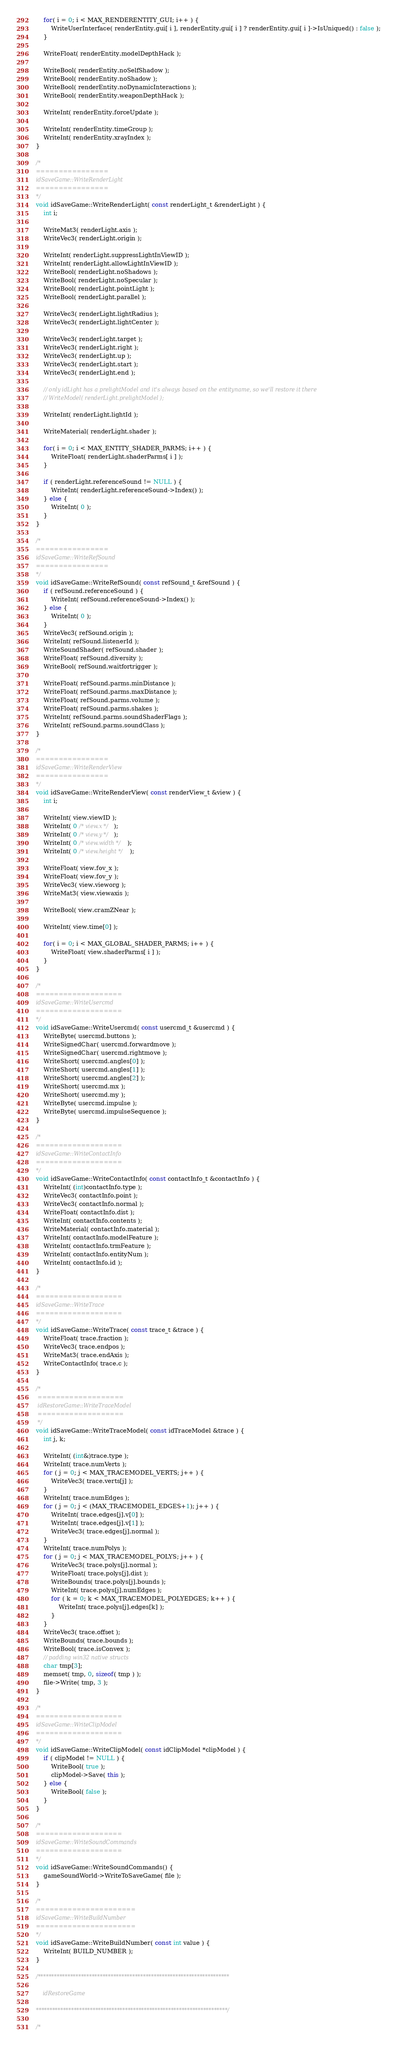Convert code to text. <code><loc_0><loc_0><loc_500><loc_500><_C++_>
	for( i = 0; i < MAX_RENDERENTITY_GUI; i++ ) {
		WriteUserInterface( renderEntity.gui[ i ], renderEntity.gui[ i ] ? renderEntity.gui[ i ]->IsUniqued() : false );
	}

	WriteFloat( renderEntity.modelDepthHack );

	WriteBool( renderEntity.noSelfShadow );
	WriteBool( renderEntity.noShadow );
	WriteBool( renderEntity.noDynamicInteractions );
	WriteBool( renderEntity.weaponDepthHack );

	WriteInt( renderEntity.forceUpdate );

	WriteInt( renderEntity.timeGroup );
	WriteInt( renderEntity.xrayIndex );
}

/*
================
idSaveGame::WriteRenderLight
================
*/
void idSaveGame::WriteRenderLight( const renderLight_t &renderLight ) {
	int i;

	WriteMat3( renderLight.axis );
	WriteVec3( renderLight.origin );

	WriteInt( renderLight.suppressLightInViewID );
	WriteInt( renderLight.allowLightInViewID );
	WriteBool( renderLight.noShadows );
	WriteBool( renderLight.noSpecular );
	WriteBool( renderLight.pointLight );
	WriteBool( renderLight.parallel );

	WriteVec3( renderLight.lightRadius );
	WriteVec3( renderLight.lightCenter );

	WriteVec3( renderLight.target );
	WriteVec3( renderLight.right );
	WriteVec3( renderLight.up );
	WriteVec3( renderLight.start );
	WriteVec3( renderLight.end );

	// only idLight has a prelightModel and it's always based on the entityname, so we'll restore it there
	// WriteModel( renderLight.prelightModel );

	WriteInt( renderLight.lightId );

	WriteMaterial( renderLight.shader );

	for( i = 0; i < MAX_ENTITY_SHADER_PARMS; i++ ) {
		WriteFloat( renderLight.shaderParms[ i ] );
	}

	if ( renderLight.referenceSound != NULL ) {
		WriteInt( renderLight.referenceSound->Index() );
	} else {
		WriteInt( 0 );
	}
}

/*
================
idSaveGame::WriteRefSound
================
*/
void idSaveGame::WriteRefSound( const refSound_t &refSound ) {
	if ( refSound.referenceSound ) {
		WriteInt( refSound.referenceSound->Index() );
	} else {
		WriteInt( 0 );
	}
	WriteVec3( refSound.origin );
	WriteInt( refSound.listenerId );
	WriteSoundShader( refSound.shader );
	WriteFloat( refSound.diversity );
	WriteBool( refSound.waitfortrigger );

	WriteFloat( refSound.parms.minDistance );
	WriteFloat( refSound.parms.maxDistance );
	WriteFloat( refSound.parms.volume );
	WriteFloat( refSound.parms.shakes );
	WriteInt( refSound.parms.soundShaderFlags );
	WriteInt( refSound.parms.soundClass );
}

/*
================
idSaveGame::WriteRenderView
================
*/
void idSaveGame::WriteRenderView( const renderView_t &view ) {
	int i;

	WriteInt( view.viewID );
	WriteInt( 0 /* view.x */ );
	WriteInt( 0 /* view.y */ );
	WriteInt( 0 /* view.width */ );
	WriteInt( 0 /* view.height */ );

	WriteFloat( view.fov_x );
	WriteFloat( view.fov_y );
	WriteVec3( view.vieworg );
	WriteMat3( view.viewaxis );

	WriteBool( view.cramZNear );

	WriteInt( view.time[0] );

	for( i = 0; i < MAX_GLOBAL_SHADER_PARMS; i++ ) {
		WriteFloat( view.shaderParms[ i ] );
	}
}

/*
===================
idSaveGame::WriteUsercmd
===================
*/
void idSaveGame::WriteUsercmd( const usercmd_t &usercmd ) {
	WriteByte( usercmd.buttons );
	WriteSignedChar( usercmd.forwardmove );
	WriteSignedChar( usercmd.rightmove );
	WriteShort( usercmd.angles[0] );
	WriteShort( usercmd.angles[1] );
	WriteShort( usercmd.angles[2] );
	WriteShort( usercmd.mx );
	WriteShort( usercmd.my );
	WriteByte( usercmd.impulse );
	WriteByte( usercmd.impulseSequence );
}

/*
===================
idSaveGame::WriteContactInfo
===================
*/
void idSaveGame::WriteContactInfo( const contactInfo_t &contactInfo ) {
	WriteInt( (int)contactInfo.type );
	WriteVec3( contactInfo.point );
	WriteVec3( contactInfo.normal );
	WriteFloat( contactInfo.dist );
	WriteInt( contactInfo.contents );
	WriteMaterial( contactInfo.material );
	WriteInt( contactInfo.modelFeature );
	WriteInt( contactInfo.trmFeature );
	WriteInt( contactInfo.entityNum );
	WriteInt( contactInfo.id );
}

/*
===================
idSaveGame::WriteTrace
===================
*/
void idSaveGame::WriteTrace( const trace_t &trace ) {
	WriteFloat( trace.fraction );
	WriteVec3( trace.endpos );
	WriteMat3( trace.endAxis );
	WriteContactInfo( trace.c );
}

/*
 ===================
 idRestoreGame::WriteTraceModel
 ===================
 */
void idSaveGame::WriteTraceModel( const idTraceModel &trace ) {
	int j, k;
	
	WriteInt( (int&)trace.type );
	WriteInt( trace.numVerts );
	for ( j = 0; j < MAX_TRACEMODEL_VERTS; j++ ) {
		WriteVec3( trace.verts[j] );
	}
	WriteInt( trace.numEdges );
	for ( j = 0; j < (MAX_TRACEMODEL_EDGES+1); j++ ) {
		WriteInt( trace.edges[j].v[0] );
		WriteInt( trace.edges[j].v[1] );
		WriteVec3( trace.edges[j].normal );
	}
	WriteInt( trace.numPolys );
	for ( j = 0; j < MAX_TRACEMODEL_POLYS; j++ ) {
		WriteVec3( trace.polys[j].normal );
		WriteFloat( trace.polys[j].dist );
		WriteBounds( trace.polys[j].bounds );
		WriteInt( trace.polys[j].numEdges );
		for ( k = 0; k < MAX_TRACEMODEL_POLYEDGES; k++ ) {
			WriteInt( trace.polys[j].edges[k] );
		}
	}
	WriteVec3( trace.offset );
	WriteBounds( trace.bounds );
	WriteBool( trace.isConvex );
	// padding win32 native structs
	char tmp[3];
	memset( tmp, 0, sizeof( tmp ) );
	file->Write( tmp, 3 );
}

/*
===================
idSaveGame::WriteClipModel
===================
*/
void idSaveGame::WriteClipModel( const idClipModel *clipModel ) {
	if ( clipModel != NULL ) {
		WriteBool( true );
		clipModel->Save( this );
	} else {
		WriteBool( false );
	}
}

/*
===================
idSaveGame::WriteSoundCommands
===================
*/
void idSaveGame::WriteSoundCommands() {
	gameSoundWorld->WriteToSaveGame( file );
}

/*
======================
idSaveGame::WriteBuildNumber
======================
*/
void idSaveGame::WriteBuildNumber( const int value ) {
	WriteInt( BUILD_NUMBER );
}

/***********************************************************************

	idRestoreGame
	
***********************************************************************/

/*</code> 